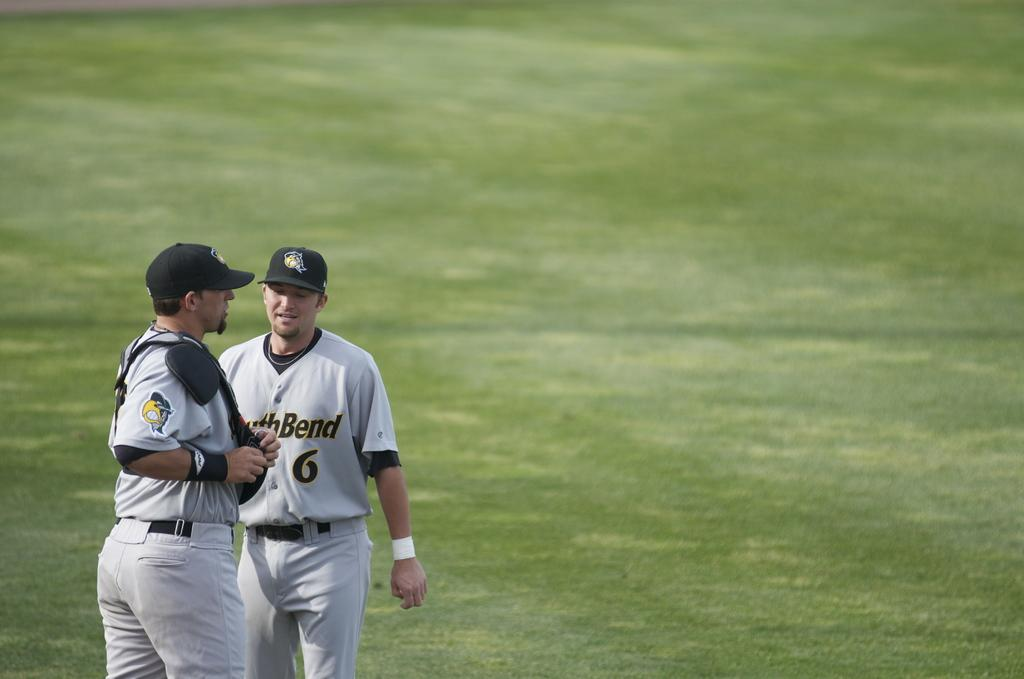<image>
Present a compact description of the photo's key features. Two South Bend baseball players, including number 6, gather together in a field to talk. 